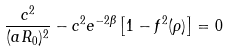<formula> <loc_0><loc_0><loc_500><loc_500>\frac { c ^ { 2 } } { ( a R _ { 0 } ) ^ { 2 } } - c ^ { 2 } e ^ { - 2 \beta } \left [ 1 - f ^ { 2 } ( \rho ) \right ] = 0</formula> 